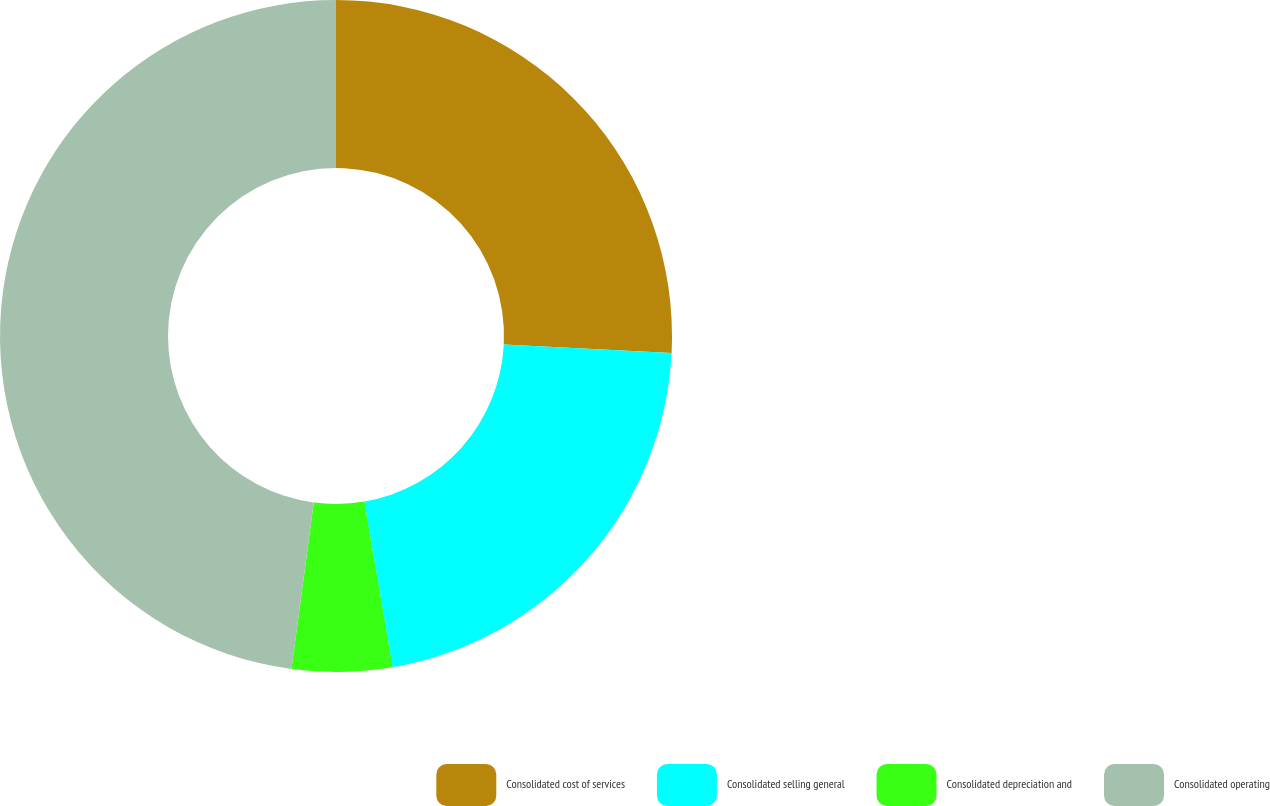<chart> <loc_0><loc_0><loc_500><loc_500><pie_chart><fcel>Consolidated cost of services<fcel>Consolidated selling general<fcel>Consolidated depreciation and<fcel>Consolidated operating<nl><fcel>25.8%<fcel>21.5%<fcel>4.81%<fcel>47.88%<nl></chart> 